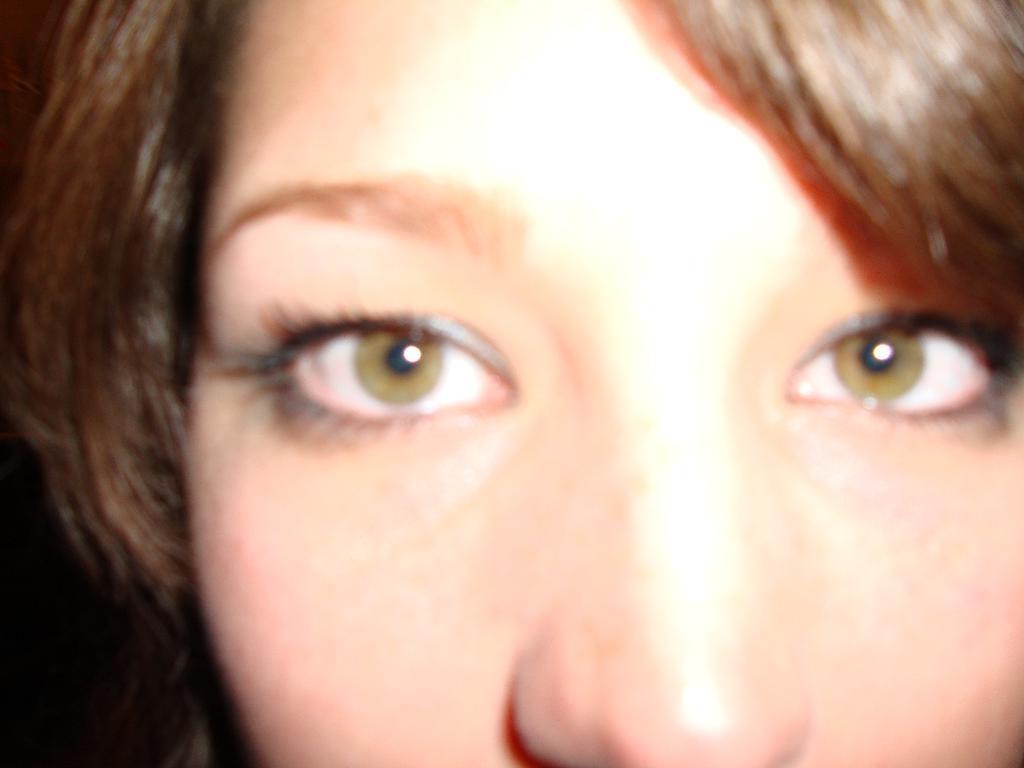How would you summarize this image in a sentence or two? In this image, we can see the face of a person. 